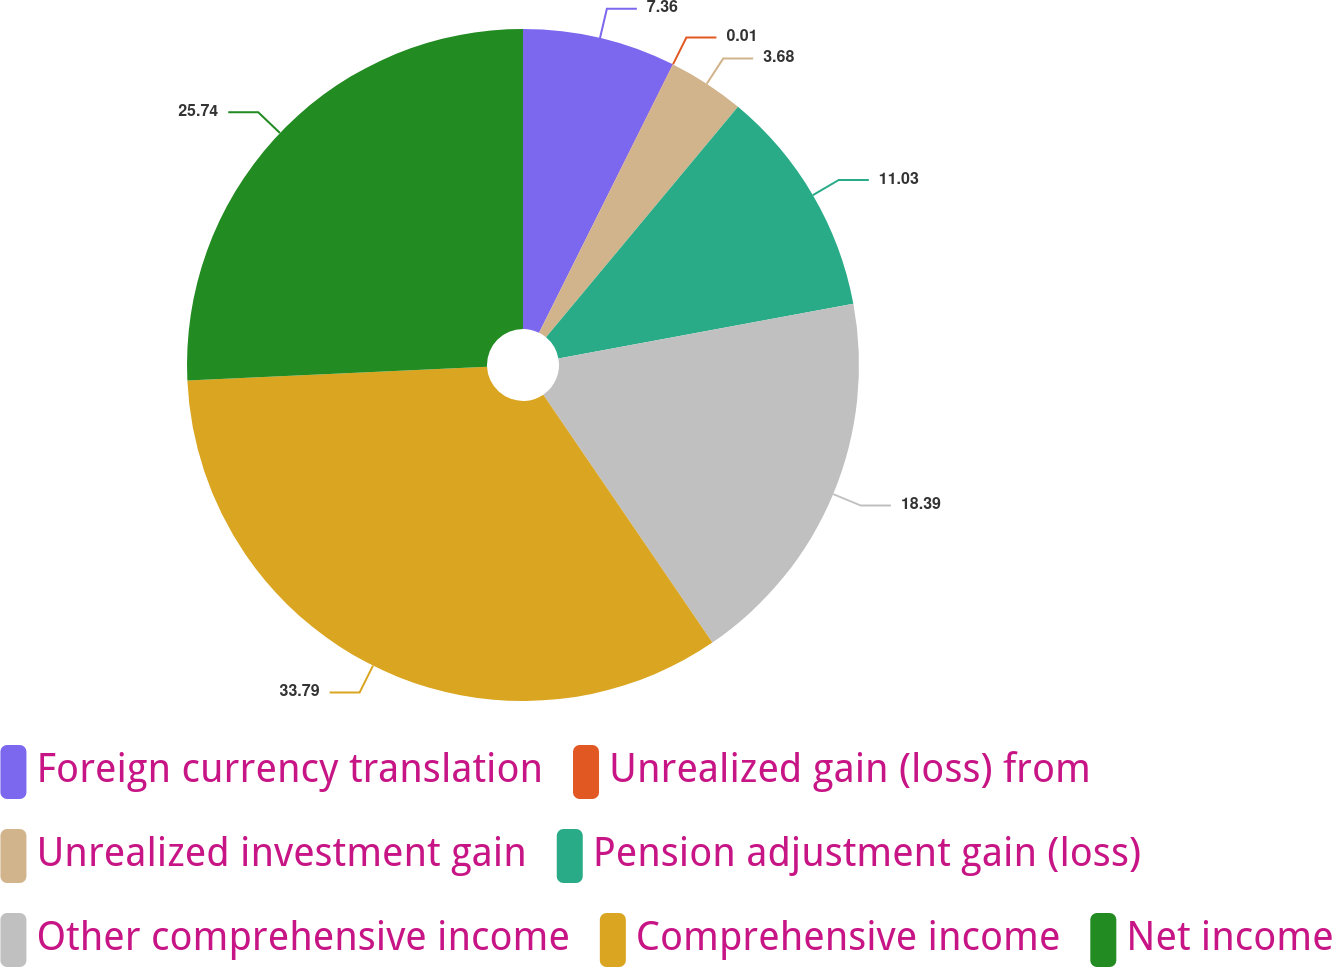<chart> <loc_0><loc_0><loc_500><loc_500><pie_chart><fcel>Foreign currency translation<fcel>Unrealized gain (loss) from<fcel>Unrealized investment gain<fcel>Pension adjustment gain (loss)<fcel>Other comprehensive income<fcel>Comprehensive income<fcel>Net income<nl><fcel>7.36%<fcel>0.01%<fcel>3.68%<fcel>11.03%<fcel>18.39%<fcel>33.79%<fcel>25.74%<nl></chart> 